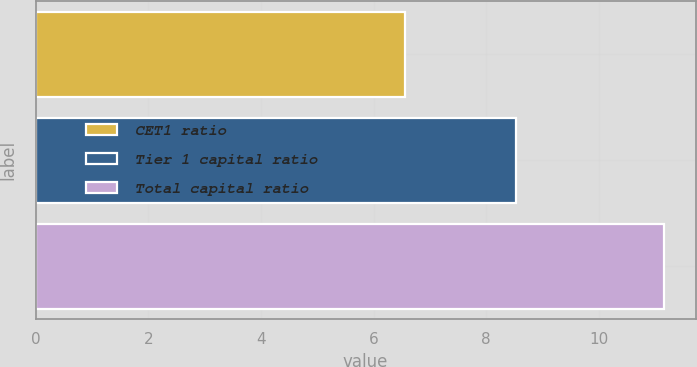<chart> <loc_0><loc_0><loc_500><loc_500><bar_chart><fcel>CET1 ratio<fcel>Tier 1 capital ratio<fcel>Total capital ratio<nl><fcel>6.55<fcel>8.53<fcel>11.16<nl></chart> 